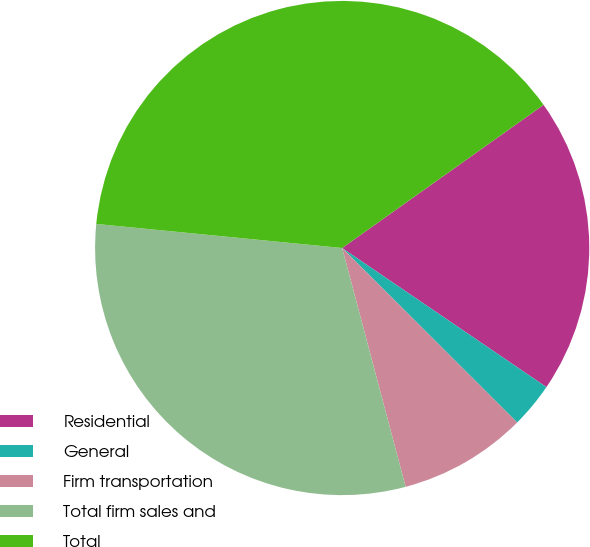Convert chart to OTSL. <chart><loc_0><loc_0><loc_500><loc_500><pie_chart><fcel>Residential<fcel>General<fcel>Firm transportation<fcel>Total firm sales and<fcel>Total<nl><fcel>19.35%<fcel>2.96%<fcel>8.39%<fcel>30.69%<fcel>38.61%<nl></chart> 